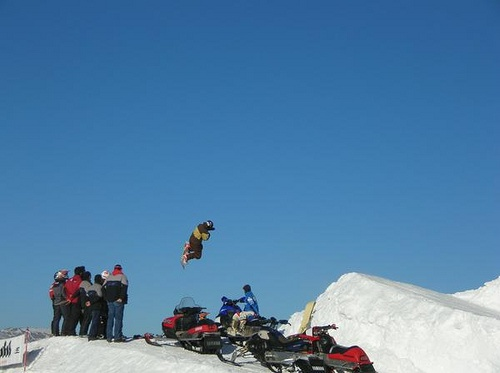Describe the objects in this image and their specific colors. I can see motorcycle in blue, black, gray, brown, and maroon tones, people in blue, black, darkblue, and gray tones, people in blue, black, maroon, and brown tones, people in blue, black, gray, and darkgray tones, and people in blue, black, gray, and maroon tones in this image. 